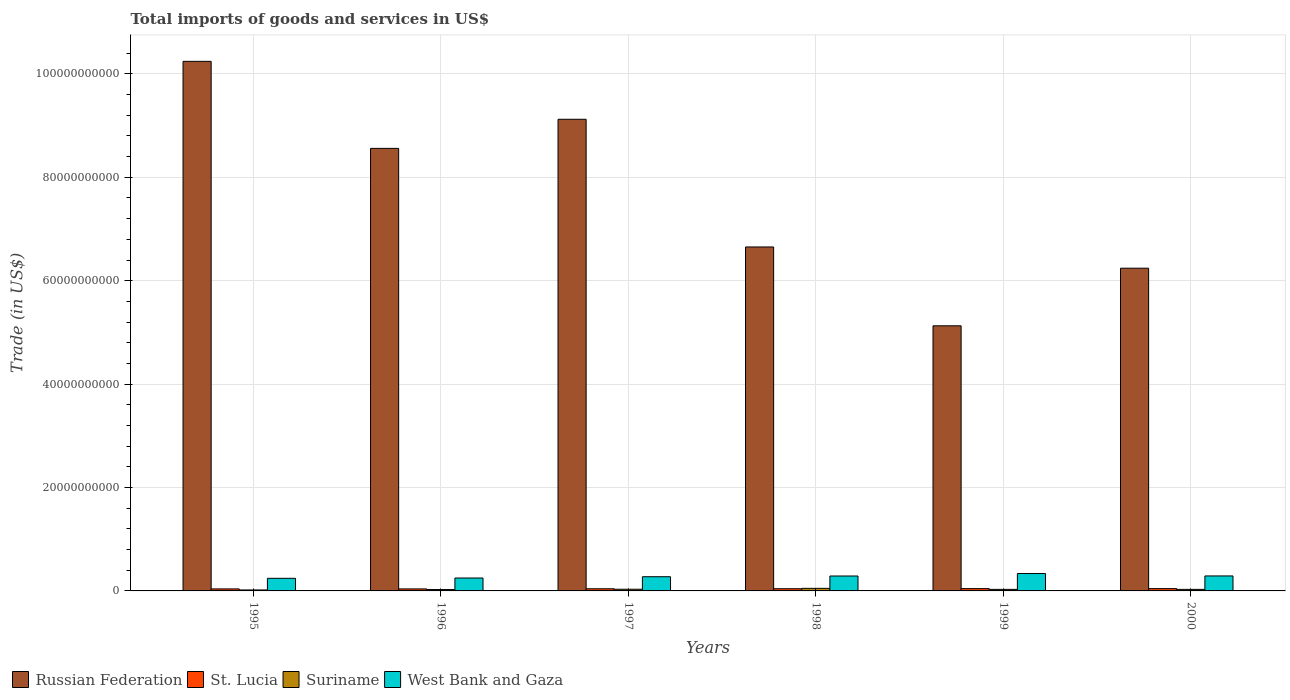How many groups of bars are there?
Offer a terse response. 6. Are the number of bars per tick equal to the number of legend labels?
Offer a very short reply. Yes. Are the number of bars on each tick of the X-axis equal?
Your answer should be compact. Yes. How many bars are there on the 3rd tick from the left?
Provide a short and direct response. 4. How many bars are there on the 2nd tick from the right?
Ensure brevity in your answer.  4. What is the total imports of goods and services in Suriname in 2000?
Provide a succinct answer. 2.96e+08. Across all years, what is the maximum total imports of goods and services in Suriname?
Provide a succinct answer. 4.96e+08. Across all years, what is the minimum total imports of goods and services in Suriname?
Make the answer very short. 1.89e+08. What is the total total imports of goods and services in Russian Federation in the graph?
Your answer should be compact. 4.59e+11. What is the difference between the total imports of goods and services in Suriname in 1997 and that in 2000?
Your answer should be compact. 2.73e+07. What is the difference between the total imports of goods and services in West Bank and Gaza in 1996 and the total imports of goods and services in Suriname in 1995?
Your response must be concise. 2.31e+09. What is the average total imports of goods and services in Suriname per year?
Offer a very short reply. 3.11e+08. In the year 2000, what is the difference between the total imports of goods and services in Suriname and total imports of goods and services in West Bank and Gaza?
Keep it short and to the point. -2.60e+09. What is the ratio of the total imports of goods and services in Suriname in 1997 to that in 1999?
Your response must be concise. 1.09. Is the total imports of goods and services in West Bank and Gaza in 1997 less than that in 2000?
Offer a very short reply. Yes. What is the difference between the highest and the second highest total imports of goods and services in West Bank and Gaza?
Make the answer very short. 4.66e+08. What is the difference between the highest and the lowest total imports of goods and services in Russian Federation?
Ensure brevity in your answer.  5.11e+1. Is the sum of the total imports of goods and services in West Bank and Gaza in 1996 and 1997 greater than the maximum total imports of goods and services in Russian Federation across all years?
Give a very brief answer. No. What does the 3rd bar from the left in 1995 represents?
Your answer should be compact. Suriname. What does the 3rd bar from the right in 1995 represents?
Your answer should be compact. St. Lucia. Is it the case that in every year, the sum of the total imports of goods and services in Suriname and total imports of goods and services in West Bank and Gaza is greater than the total imports of goods and services in Russian Federation?
Provide a short and direct response. No. Are all the bars in the graph horizontal?
Ensure brevity in your answer.  No. What is the difference between two consecutive major ticks on the Y-axis?
Keep it short and to the point. 2.00e+1. Are the values on the major ticks of Y-axis written in scientific E-notation?
Give a very brief answer. No. Does the graph contain grids?
Offer a very short reply. Yes. Where does the legend appear in the graph?
Offer a terse response. Bottom left. How are the legend labels stacked?
Your answer should be compact. Horizontal. What is the title of the graph?
Offer a terse response. Total imports of goods and services in US$. Does "Eritrea" appear as one of the legend labels in the graph?
Give a very brief answer. No. What is the label or title of the X-axis?
Make the answer very short. Years. What is the label or title of the Y-axis?
Provide a short and direct response. Trade (in US$). What is the Trade (in US$) of Russian Federation in 1995?
Keep it short and to the point. 1.02e+11. What is the Trade (in US$) of St. Lucia in 1995?
Make the answer very short. 3.89e+08. What is the Trade (in US$) in Suriname in 1995?
Keep it short and to the point. 1.89e+08. What is the Trade (in US$) in West Bank and Gaza in 1995?
Your answer should be very brief. 2.44e+09. What is the Trade (in US$) of Russian Federation in 1996?
Offer a terse response. 8.56e+1. What is the Trade (in US$) of St. Lucia in 1996?
Provide a succinct answer. 3.88e+08. What is the Trade (in US$) of Suriname in 1996?
Provide a succinct answer. 2.65e+08. What is the Trade (in US$) in West Bank and Gaza in 1996?
Make the answer very short. 2.50e+09. What is the Trade (in US$) in Russian Federation in 1997?
Provide a short and direct response. 9.12e+1. What is the Trade (in US$) in St. Lucia in 1997?
Offer a very short reply. 4.14e+08. What is the Trade (in US$) in Suriname in 1997?
Your answer should be compact. 3.23e+08. What is the Trade (in US$) in West Bank and Gaza in 1997?
Offer a very short reply. 2.75e+09. What is the Trade (in US$) of Russian Federation in 1998?
Provide a short and direct response. 6.65e+1. What is the Trade (in US$) of St. Lucia in 1998?
Provide a short and direct response. 4.24e+08. What is the Trade (in US$) in Suriname in 1998?
Offer a terse response. 4.96e+08. What is the Trade (in US$) in West Bank and Gaza in 1998?
Give a very brief answer. 2.89e+09. What is the Trade (in US$) in Russian Federation in 1999?
Provide a succinct answer. 5.13e+1. What is the Trade (in US$) of St. Lucia in 1999?
Offer a very short reply. 4.45e+08. What is the Trade (in US$) of Suriname in 1999?
Give a very brief answer. 2.98e+08. What is the Trade (in US$) of West Bank and Gaza in 1999?
Your answer should be very brief. 3.36e+09. What is the Trade (in US$) in Russian Federation in 2000?
Keep it short and to the point. 6.24e+1. What is the Trade (in US$) in St. Lucia in 2000?
Your answer should be very brief. 4.46e+08. What is the Trade (in US$) of Suriname in 2000?
Provide a short and direct response. 2.96e+08. What is the Trade (in US$) in West Bank and Gaza in 2000?
Provide a succinct answer. 2.90e+09. Across all years, what is the maximum Trade (in US$) in Russian Federation?
Offer a terse response. 1.02e+11. Across all years, what is the maximum Trade (in US$) in St. Lucia?
Provide a short and direct response. 4.46e+08. Across all years, what is the maximum Trade (in US$) of Suriname?
Your response must be concise. 4.96e+08. Across all years, what is the maximum Trade (in US$) in West Bank and Gaza?
Offer a very short reply. 3.36e+09. Across all years, what is the minimum Trade (in US$) in Russian Federation?
Keep it short and to the point. 5.13e+1. Across all years, what is the minimum Trade (in US$) in St. Lucia?
Offer a terse response. 3.88e+08. Across all years, what is the minimum Trade (in US$) in Suriname?
Provide a short and direct response. 1.89e+08. Across all years, what is the minimum Trade (in US$) in West Bank and Gaza?
Offer a very short reply. 2.44e+09. What is the total Trade (in US$) of Russian Federation in the graph?
Offer a very short reply. 4.59e+11. What is the total Trade (in US$) of St. Lucia in the graph?
Offer a terse response. 2.51e+09. What is the total Trade (in US$) of Suriname in the graph?
Give a very brief answer. 1.87e+09. What is the total Trade (in US$) in West Bank and Gaza in the graph?
Your answer should be compact. 1.68e+1. What is the difference between the Trade (in US$) in Russian Federation in 1995 and that in 1996?
Ensure brevity in your answer.  1.68e+1. What is the difference between the Trade (in US$) in St. Lucia in 1995 and that in 1996?
Offer a terse response. 7.00e+05. What is the difference between the Trade (in US$) of Suriname in 1995 and that in 1996?
Give a very brief answer. -7.59e+07. What is the difference between the Trade (in US$) in West Bank and Gaza in 1995 and that in 1996?
Your response must be concise. -5.62e+07. What is the difference between the Trade (in US$) in Russian Federation in 1995 and that in 1997?
Your response must be concise. 1.12e+1. What is the difference between the Trade (in US$) in St. Lucia in 1995 and that in 1997?
Make the answer very short. -2.56e+07. What is the difference between the Trade (in US$) in Suriname in 1995 and that in 1997?
Make the answer very short. -1.35e+08. What is the difference between the Trade (in US$) of West Bank and Gaza in 1995 and that in 1997?
Provide a short and direct response. -3.06e+08. What is the difference between the Trade (in US$) of Russian Federation in 1995 and that in 1998?
Make the answer very short. 3.59e+1. What is the difference between the Trade (in US$) in St. Lucia in 1995 and that in 1998?
Offer a very short reply. -3.56e+07. What is the difference between the Trade (in US$) of Suriname in 1995 and that in 1998?
Your response must be concise. -3.07e+08. What is the difference between the Trade (in US$) of West Bank and Gaza in 1995 and that in 1998?
Your answer should be very brief. -4.45e+08. What is the difference between the Trade (in US$) in Russian Federation in 1995 and that in 1999?
Offer a very short reply. 5.11e+1. What is the difference between the Trade (in US$) of St. Lucia in 1995 and that in 1999?
Make the answer very short. -5.65e+07. What is the difference between the Trade (in US$) in Suriname in 1995 and that in 1999?
Make the answer very short. -1.09e+08. What is the difference between the Trade (in US$) of West Bank and Gaza in 1995 and that in 1999?
Provide a short and direct response. -9.24e+08. What is the difference between the Trade (in US$) in Russian Federation in 1995 and that in 2000?
Provide a short and direct response. 4.00e+1. What is the difference between the Trade (in US$) of St. Lucia in 1995 and that in 2000?
Ensure brevity in your answer.  -5.72e+07. What is the difference between the Trade (in US$) of Suriname in 1995 and that in 2000?
Keep it short and to the point. -1.07e+08. What is the difference between the Trade (in US$) in West Bank and Gaza in 1995 and that in 2000?
Ensure brevity in your answer.  -4.57e+08. What is the difference between the Trade (in US$) of Russian Federation in 1996 and that in 1997?
Your answer should be compact. -5.63e+09. What is the difference between the Trade (in US$) of St. Lucia in 1996 and that in 1997?
Provide a succinct answer. -2.63e+07. What is the difference between the Trade (in US$) in Suriname in 1996 and that in 1997?
Offer a terse response. -5.87e+07. What is the difference between the Trade (in US$) in West Bank and Gaza in 1996 and that in 1997?
Give a very brief answer. -2.50e+08. What is the difference between the Trade (in US$) of Russian Federation in 1996 and that in 1998?
Provide a succinct answer. 1.91e+1. What is the difference between the Trade (in US$) of St. Lucia in 1996 and that in 1998?
Give a very brief answer. -3.63e+07. What is the difference between the Trade (in US$) in Suriname in 1996 and that in 1998?
Keep it short and to the point. -2.31e+08. What is the difference between the Trade (in US$) of West Bank and Gaza in 1996 and that in 1998?
Your answer should be compact. -3.89e+08. What is the difference between the Trade (in US$) of Russian Federation in 1996 and that in 1999?
Offer a very short reply. 3.43e+1. What is the difference between the Trade (in US$) in St. Lucia in 1996 and that in 1999?
Make the answer very short. -5.72e+07. What is the difference between the Trade (in US$) of Suriname in 1996 and that in 1999?
Offer a terse response. -3.31e+07. What is the difference between the Trade (in US$) in West Bank and Gaza in 1996 and that in 1999?
Your answer should be very brief. -8.67e+08. What is the difference between the Trade (in US$) in Russian Federation in 1996 and that in 2000?
Offer a terse response. 2.32e+1. What is the difference between the Trade (in US$) of St. Lucia in 1996 and that in 2000?
Keep it short and to the point. -5.79e+07. What is the difference between the Trade (in US$) in Suriname in 1996 and that in 2000?
Provide a short and direct response. -3.15e+07. What is the difference between the Trade (in US$) in West Bank and Gaza in 1996 and that in 2000?
Provide a short and direct response. -4.01e+08. What is the difference between the Trade (in US$) of Russian Federation in 1997 and that in 1998?
Offer a terse response. 2.47e+1. What is the difference between the Trade (in US$) in St. Lucia in 1997 and that in 1998?
Your answer should be compact. -1.00e+07. What is the difference between the Trade (in US$) in Suriname in 1997 and that in 1998?
Your answer should be very brief. -1.73e+08. What is the difference between the Trade (in US$) of West Bank and Gaza in 1997 and that in 1998?
Your answer should be very brief. -1.39e+08. What is the difference between the Trade (in US$) in Russian Federation in 1997 and that in 1999?
Keep it short and to the point. 3.99e+1. What is the difference between the Trade (in US$) of St. Lucia in 1997 and that in 1999?
Provide a short and direct response. -3.09e+07. What is the difference between the Trade (in US$) of Suriname in 1997 and that in 1999?
Provide a succinct answer. 2.56e+07. What is the difference between the Trade (in US$) of West Bank and Gaza in 1997 and that in 1999?
Keep it short and to the point. -6.17e+08. What is the difference between the Trade (in US$) of Russian Federation in 1997 and that in 2000?
Your response must be concise. 2.88e+1. What is the difference between the Trade (in US$) in St. Lucia in 1997 and that in 2000?
Give a very brief answer. -3.17e+07. What is the difference between the Trade (in US$) of Suriname in 1997 and that in 2000?
Offer a very short reply. 2.73e+07. What is the difference between the Trade (in US$) in West Bank and Gaza in 1997 and that in 2000?
Give a very brief answer. -1.51e+08. What is the difference between the Trade (in US$) of Russian Federation in 1998 and that in 1999?
Provide a short and direct response. 1.52e+1. What is the difference between the Trade (in US$) of St. Lucia in 1998 and that in 1999?
Your response must be concise. -2.08e+07. What is the difference between the Trade (in US$) in Suriname in 1998 and that in 1999?
Your answer should be compact. 1.98e+08. What is the difference between the Trade (in US$) of West Bank and Gaza in 1998 and that in 1999?
Ensure brevity in your answer.  -4.78e+08. What is the difference between the Trade (in US$) in Russian Federation in 1998 and that in 2000?
Give a very brief answer. 4.11e+09. What is the difference between the Trade (in US$) of St. Lucia in 1998 and that in 2000?
Your response must be concise. -2.16e+07. What is the difference between the Trade (in US$) of Suriname in 1998 and that in 2000?
Ensure brevity in your answer.  2.00e+08. What is the difference between the Trade (in US$) of West Bank and Gaza in 1998 and that in 2000?
Ensure brevity in your answer.  -1.18e+07. What is the difference between the Trade (in US$) of Russian Federation in 1999 and that in 2000?
Offer a terse response. -1.11e+1. What is the difference between the Trade (in US$) of St. Lucia in 1999 and that in 2000?
Give a very brief answer. -7.96e+05. What is the difference between the Trade (in US$) of Suriname in 1999 and that in 2000?
Provide a succinct answer. 1.62e+06. What is the difference between the Trade (in US$) of West Bank and Gaza in 1999 and that in 2000?
Ensure brevity in your answer.  4.66e+08. What is the difference between the Trade (in US$) in Russian Federation in 1995 and the Trade (in US$) in St. Lucia in 1996?
Your answer should be very brief. 1.02e+11. What is the difference between the Trade (in US$) in Russian Federation in 1995 and the Trade (in US$) in Suriname in 1996?
Make the answer very short. 1.02e+11. What is the difference between the Trade (in US$) of Russian Federation in 1995 and the Trade (in US$) of West Bank and Gaza in 1996?
Ensure brevity in your answer.  9.99e+1. What is the difference between the Trade (in US$) of St. Lucia in 1995 and the Trade (in US$) of Suriname in 1996?
Provide a short and direct response. 1.24e+08. What is the difference between the Trade (in US$) in St. Lucia in 1995 and the Trade (in US$) in West Bank and Gaza in 1996?
Ensure brevity in your answer.  -2.11e+09. What is the difference between the Trade (in US$) of Suriname in 1995 and the Trade (in US$) of West Bank and Gaza in 1996?
Your response must be concise. -2.31e+09. What is the difference between the Trade (in US$) in Russian Federation in 1995 and the Trade (in US$) in St. Lucia in 1997?
Provide a short and direct response. 1.02e+11. What is the difference between the Trade (in US$) of Russian Federation in 1995 and the Trade (in US$) of Suriname in 1997?
Keep it short and to the point. 1.02e+11. What is the difference between the Trade (in US$) of Russian Federation in 1995 and the Trade (in US$) of West Bank and Gaza in 1997?
Offer a very short reply. 9.97e+1. What is the difference between the Trade (in US$) of St. Lucia in 1995 and the Trade (in US$) of Suriname in 1997?
Your answer should be compact. 6.53e+07. What is the difference between the Trade (in US$) in St. Lucia in 1995 and the Trade (in US$) in West Bank and Gaza in 1997?
Ensure brevity in your answer.  -2.36e+09. What is the difference between the Trade (in US$) in Suriname in 1995 and the Trade (in US$) in West Bank and Gaza in 1997?
Your answer should be very brief. -2.56e+09. What is the difference between the Trade (in US$) in Russian Federation in 1995 and the Trade (in US$) in St. Lucia in 1998?
Your answer should be very brief. 1.02e+11. What is the difference between the Trade (in US$) in Russian Federation in 1995 and the Trade (in US$) in Suriname in 1998?
Your answer should be very brief. 1.02e+11. What is the difference between the Trade (in US$) of Russian Federation in 1995 and the Trade (in US$) of West Bank and Gaza in 1998?
Your answer should be compact. 9.95e+1. What is the difference between the Trade (in US$) of St. Lucia in 1995 and the Trade (in US$) of Suriname in 1998?
Ensure brevity in your answer.  -1.07e+08. What is the difference between the Trade (in US$) in St. Lucia in 1995 and the Trade (in US$) in West Bank and Gaza in 1998?
Offer a terse response. -2.50e+09. What is the difference between the Trade (in US$) of Suriname in 1995 and the Trade (in US$) of West Bank and Gaza in 1998?
Offer a very short reply. -2.70e+09. What is the difference between the Trade (in US$) of Russian Federation in 1995 and the Trade (in US$) of St. Lucia in 1999?
Make the answer very short. 1.02e+11. What is the difference between the Trade (in US$) in Russian Federation in 1995 and the Trade (in US$) in Suriname in 1999?
Offer a terse response. 1.02e+11. What is the difference between the Trade (in US$) in Russian Federation in 1995 and the Trade (in US$) in West Bank and Gaza in 1999?
Provide a short and direct response. 9.91e+1. What is the difference between the Trade (in US$) of St. Lucia in 1995 and the Trade (in US$) of Suriname in 1999?
Your answer should be very brief. 9.09e+07. What is the difference between the Trade (in US$) in St. Lucia in 1995 and the Trade (in US$) in West Bank and Gaza in 1999?
Your response must be concise. -2.98e+09. What is the difference between the Trade (in US$) of Suriname in 1995 and the Trade (in US$) of West Bank and Gaza in 1999?
Ensure brevity in your answer.  -3.17e+09. What is the difference between the Trade (in US$) in Russian Federation in 1995 and the Trade (in US$) in St. Lucia in 2000?
Your answer should be very brief. 1.02e+11. What is the difference between the Trade (in US$) in Russian Federation in 1995 and the Trade (in US$) in Suriname in 2000?
Keep it short and to the point. 1.02e+11. What is the difference between the Trade (in US$) of Russian Federation in 1995 and the Trade (in US$) of West Bank and Gaza in 2000?
Your response must be concise. 9.95e+1. What is the difference between the Trade (in US$) in St. Lucia in 1995 and the Trade (in US$) in Suriname in 2000?
Offer a terse response. 9.25e+07. What is the difference between the Trade (in US$) in St. Lucia in 1995 and the Trade (in US$) in West Bank and Gaza in 2000?
Give a very brief answer. -2.51e+09. What is the difference between the Trade (in US$) of Suriname in 1995 and the Trade (in US$) of West Bank and Gaza in 2000?
Offer a terse response. -2.71e+09. What is the difference between the Trade (in US$) of Russian Federation in 1996 and the Trade (in US$) of St. Lucia in 1997?
Your response must be concise. 8.52e+1. What is the difference between the Trade (in US$) of Russian Federation in 1996 and the Trade (in US$) of Suriname in 1997?
Ensure brevity in your answer.  8.53e+1. What is the difference between the Trade (in US$) in Russian Federation in 1996 and the Trade (in US$) in West Bank and Gaza in 1997?
Offer a terse response. 8.28e+1. What is the difference between the Trade (in US$) in St. Lucia in 1996 and the Trade (in US$) in Suriname in 1997?
Keep it short and to the point. 6.46e+07. What is the difference between the Trade (in US$) in St. Lucia in 1996 and the Trade (in US$) in West Bank and Gaza in 1997?
Give a very brief answer. -2.36e+09. What is the difference between the Trade (in US$) in Suriname in 1996 and the Trade (in US$) in West Bank and Gaza in 1997?
Make the answer very short. -2.48e+09. What is the difference between the Trade (in US$) of Russian Federation in 1996 and the Trade (in US$) of St. Lucia in 1998?
Provide a succinct answer. 8.52e+1. What is the difference between the Trade (in US$) in Russian Federation in 1996 and the Trade (in US$) in Suriname in 1998?
Your answer should be compact. 8.51e+1. What is the difference between the Trade (in US$) of Russian Federation in 1996 and the Trade (in US$) of West Bank and Gaza in 1998?
Offer a very short reply. 8.27e+1. What is the difference between the Trade (in US$) in St. Lucia in 1996 and the Trade (in US$) in Suriname in 1998?
Offer a terse response. -1.08e+08. What is the difference between the Trade (in US$) in St. Lucia in 1996 and the Trade (in US$) in West Bank and Gaza in 1998?
Make the answer very short. -2.50e+09. What is the difference between the Trade (in US$) in Suriname in 1996 and the Trade (in US$) in West Bank and Gaza in 1998?
Your answer should be compact. -2.62e+09. What is the difference between the Trade (in US$) in Russian Federation in 1996 and the Trade (in US$) in St. Lucia in 1999?
Keep it short and to the point. 8.51e+1. What is the difference between the Trade (in US$) in Russian Federation in 1996 and the Trade (in US$) in Suriname in 1999?
Give a very brief answer. 8.53e+1. What is the difference between the Trade (in US$) of Russian Federation in 1996 and the Trade (in US$) of West Bank and Gaza in 1999?
Provide a short and direct response. 8.22e+1. What is the difference between the Trade (in US$) of St. Lucia in 1996 and the Trade (in US$) of Suriname in 1999?
Offer a very short reply. 9.02e+07. What is the difference between the Trade (in US$) of St. Lucia in 1996 and the Trade (in US$) of West Bank and Gaza in 1999?
Ensure brevity in your answer.  -2.98e+09. What is the difference between the Trade (in US$) of Suriname in 1996 and the Trade (in US$) of West Bank and Gaza in 1999?
Offer a very short reply. -3.10e+09. What is the difference between the Trade (in US$) of Russian Federation in 1996 and the Trade (in US$) of St. Lucia in 2000?
Offer a very short reply. 8.51e+1. What is the difference between the Trade (in US$) in Russian Federation in 1996 and the Trade (in US$) in Suriname in 2000?
Ensure brevity in your answer.  8.53e+1. What is the difference between the Trade (in US$) in Russian Federation in 1996 and the Trade (in US$) in West Bank and Gaza in 2000?
Provide a succinct answer. 8.27e+1. What is the difference between the Trade (in US$) of St. Lucia in 1996 and the Trade (in US$) of Suriname in 2000?
Give a very brief answer. 9.18e+07. What is the difference between the Trade (in US$) of St. Lucia in 1996 and the Trade (in US$) of West Bank and Gaza in 2000?
Give a very brief answer. -2.51e+09. What is the difference between the Trade (in US$) of Suriname in 1996 and the Trade (in US$) of West Bank and Gaza in 2000?
Provide a short and direct response. -2.63e+09. What is the difference between the Trade (in US$) of Russian Federation in 1997 and the Trade (in US$) of St. Lucia in 1998?
Provide a short and direct response. 9.08e+1. What is the difference between the Trade (in US$) in Russian Federation in 1997 and the Trade (in US$) in Suriname in 1998?
Keep it short and to the point. 9.07e+1. What is the difference between the Trade (in US$) of Russian Federation in 1997 and the Trade (in US$) of West Bank and Gaza in 1998?
Your response must be concise. 8.83e+1. What is the difference between the Trade (in US$) of St. Lucia in 1997 and the Trade (in US$) of Suriname in 1998?
Offer a terse response. -8.17e+07. What is the difference between the Trade (in US$) of St. Lucia in 1997 and the Trade (in US$) of West Bank and Gaza in 1998?
Give a very brief answer. -2.47e+09. What is the difference between the Trade (in US$) of Suriname in 1997 and the Trade (in US$) of West Bank and Gaza in 1998?
Your answer should be compact. -2.56e+09. What is the difference between the Trade (in US$) in Russian Federation in 1997 and the Trade (in US$) in St. Lucia in 1999?
Give a very brief answer. 9.08e+1. What is the difference between the Trade (in US$) of Russian Federation in 1997 and the Trade (in US$) of Suriname in 1999?
Your answer should be compact. 9.09e+1. What is the difference between the Trade (in US$) in Russian Federation in 1997 and the Trade (in US$) in West Bank and Gaza in 1999?
Offer a terse response. 8.79e+1. What is the difference between the Trade (in US$) of St. Lucia in 1997 and the Trade (in US$) of Suriname in 1999?
Your answer should be very brief. 1.16e+08. What is the difference between the Trade (in US$) in St. Lucia in 1997 and the Trade (in US$) in West Bank and Gaza in 1999?
Your response must be concise. -2.95e+09. What is the difference between the Trade (in US$) of Suriname in 1997 and the Trade (in US$) of West Bank and Gaza in 1999?
Offer a terse response. -3.04e+09. What is the difference between the Trade (in US$) of Russian Federation in 1997 and the Trade (in US$) of St. Lucia in 2000?
Offer a very short reply. 9.08e+1. What is the difference between the Trade (in US$) in Russian Federation in 1997 and the Trade (in US$) in Suriname in 2000?
Keep it short and to the point. 9.09e+1. What is the difference between the Trade (in US$) in Russian Federation in 1997 and the Trade (in US$) in West Bank and Gaza in 2000?
Your answer should be very brief. 8.83e+1. What is the difference between the Trade (in US$) of St. Lucia in 1997 and the Trade (in US$) of Suriname in 2000?
Offer a terse response. 1.18e+08. What is the difference between the Trade (in US$) in St. Lucia in 1997 and the Trade (in US$) in West Bank and Gaza in 2000?
Ensure brevity in your answer.  -2.48e+09. What is the difference between the Trade (in US$) in Suriname in 1997 and the Trade (in US$) in West Bank and Gaza in 2000?
Ensure brevity in your answer.  -2.57e+09. What is the difference between the Trade (in US$) in Russian Federation in 1998 and the Trade (in US$) in St. Lucia in 1999?
Ensure brevity in your answer.  6.61e+1. What is the difference between the Trade (in US$) in Russian Federation in 1998 and the Trade (in US$) in Suriname in 1999?
Your answer should be compact. 6.62e+1. What is the difference between the Trade (in US$) in Russian Federation in 1998 and the Trade (in US$) in West Bank and Gaza in 1999?
Provide a short and direct response. 6.32e+1. What is the difference between the Trade (in US$) in St. Lucia in 1998 and the Trade (in US$) in Suriname in 1999?
Provide a short and direct response. 1.27e+08. What is the difference between the Trade (in US$) of St. Lucia in 1998 and the Trade (in US$) of West Bank and Gaza in 1999?
Your answer should be very brief. -2.94e+09. What is the difference between the Trade (in US$) of Suriname in 1998 and the Trade (in US$) of West Bank and Gaza in 1999?
Offer a terse response. -2.87e+09. What is the difference between the Trade (in US$) in Russian Federation in 1998 and the Trade (in US$) in St. Lucia in 2000?
Your answer should be very brief. 6.61e+1. What is the difference between the Trade (in US$) of Russian Federation in 1998 and the Trade (in US$) of Suriname in 2000?
Your answer should be compact. 6.62e+1. What is the difference between the Trade (in US$) in Russian Federation in 1998 and the Trade (in US$) in West Bank and Gaza in 2000?
Provide a succinct answer. 6.36e+1. What is the difference between the Trade (in US$) in St. Lucia in 1998 and the Trade (in US$) in Suriname in 2000?
Your answer should be very brief. 1.28e+08. What is the difference between the Trade (in US$) of St. Lucia in 1998 and the Trade (in US$) of West Bank and Gaza in 2000?
Your response must be concise. -2.47e+09. What is the difference between the Trade (in US$) in Suriname in 1998 and the Trade (in US$) in West Bank and Gaza in 2000?
Offer a very short reply. -2.40e+09. What is the difference between the Trade (in US$) in Russian Federation in 1999 and the Trade (in US$) in St. Lucia in 2000?
Provide a short and direct response. 5.08e+1. What is the difference between the Trade (in US$) in Russian Federation in 1999 and the Trade (in US$) in Suriname in 2000?
Ensure brevity in your answer.  5.10e+1. What is the difference between the Trade (in US$) of Russian Federation in 1999 and the Trade (in US$) of West Bank and Gaza in 2000?
Your answer should be compact. 4.84e+1. What is the difference between the Trade (in US$) in St. Lucia in 1999 and the Trade (in US$) in Suriname in 2000?
Keep it short and to the point. 1.49e+08. What is the difference between the Trade (in US$) of St. Lucia in 1999 and the Trade (in US$) of West Bank and Gaza in 2000?
Provide a short and direct response. -2.45e+09. What is the difference between the Trade (in US$) in Suriname in 1999 and the Trade (in US$) in West Bank and Gaza in 2000?
Provide a short and direct response. -2.60e+09. What is the average Trade (in US$) in Russian Federation per year?
Make the answer very short. 7.66e+1. What is the average Trade (in US$) of St. Lucia per year?
Make the answer very short. 4.18e+08. What is the average Trade (in US$) in Suriname per year?
Make the answer very short. 3.11e+08. What is the average Trade (in US$) of West Bank and Gaza per year?
Provide a succinct answer. 2.80e+09. In the year 1995, what is the difference between the Trade (in US$) in Russian Federation and Trade (in US$) in St. Lucia?
Keep it short and to the point. 1.02e+11. In the year 1995, what is the difference between the Trade (in US$) of Russian Federation and Trade (in US$) of Suriname?
Provide a short and direct response. 1.02e+11. In the year 1995, what is the difference between the Trade (in US$) in Russian Federation and Trade (in US$) in West Bank and Gaza?
Make the answer very short. 1.00e+11. In the year 1995, what is the difference between the Trade (in US$) of St. Lucia and Trade (in US$) of Suriname?
Your response must be concise. 2.00e+08. In the year 1995, what is the difference between the Trade (in US$) in St. Lucia and Trade (in US$) in West Bank and Gaza?
Offer a very short reply. -2.05e+09. In the year 1995, what is the difference between the Trade (in US$) of Suriname and Trade (in US$) of West Bank and Gaza?
Provide a short and direct response. -2.25e+09. In the year 1996, what is the difference between the Trade (in US$) of Russian Federation and Trade (in US$) of St. Lucia?
Offer a very short reply. 8.52e+1. In the year 1996, what is the difference between the Trade (in US$) in Russian Federation and Trade (in US$) in Suriname?
Give a very brief answer. 8.53e+1. In the year 1996, what is the difference between the Trade (in US$) of Russian Federation and Trade (in US$) of West Bank and Gaza?
Make the answer very short. 8.31e+1. In the year 1996, what is the difference between the Trade (in US$) of St. Lucia and Trade (in US$) of Suriname?
Ensure brevity in your answer.  1.23e+08. In the year 1996, what is the difference between the Trade (in US$) of St. Lucia and Trade (in US$) of West Bank and Gaza?
Offer a very short reply. -2.11e+09. In the year 1996, what is the difference between the Trade (in US$) of Suriname and Trade (in US$) of West Bank and Gaza?
Make the answer very short. -2.23e+09. In the year 1997, what is the difference between the Trade (in US$) of Russian Federation and Trade (in US$) of St. Lucia?
Offer a terse response. 9.08e+1. In the year 1997, what is the difference between the Trade (in US$) in Russian Federation and Trade (in US$) in Suriname?
Ensure brevity in your answer.  9.09e+1. In the year 1997, what is the difference between the Trade (in US$) of Russian Federation and Trade (in US$) of West Bank and Gaza?
Provide a succinct answer. 8.85e+1. In the year 1997, what is the difference between the Trade (in US$) in St. Lucia and Trade (in US$) in Suriname?
Give a very brief answer. 9.08e+07. In the year 1997, what is the difference between the Trade (in US$) in St. Lucia and Trade (in US$) in West Bank and Gaza?
Offer a very short reply. -2.33e+09. In the year 1997, what is the difference between the Trade (in US$) in Suriname and Trade (in US$) in West Bank and Gaza?
Keep it short and to the point. -2.42e+09. In the year 1998, what is the difference between the Trade (in US$) in Russian Federation and Trade (in US$) in St. Lucia?
Offer a very short reply. 6.61e+1. In the year 1998, what is the difference between the Trade (in US$) in Russian Federation and Trade (in US$) in Suriname?
Give a very brief answer. 6.60e+1. In the year 1998, what is the difference between the Trade (in US$) of Russian Federation and Trade (in US$) of West Bank and Gaza?
Ensure brevity in your answer.  6.36e+1. In the year 1998, what is the difference between the Trade (in US$) of St. Lucia and Trade (in US$) of Suriname?
Ensure brevity in your answer.  -7.17e+07. In the year 1998, what is the difference between the Trade (in US$) in St. Lucia and Trade (in US$) in West Bank and Gaza?
Your answer should be compact. -2.46e+09. In the year 1998, what is the difference between the Trade (in US$) of Suriname and Trade (in US$) of West Bank and Gaza?
Provide a short and direct response. -2.39e+09. In the year 1999, what is the difference between the Trade (in US$) of Russian Federation and Trade (in US$) of St. Lucia?
Provide a succinct answer. 5.08e+1. In the year 1999, what is the difference between the Trade (in US$) in Russian Federation and Trade (in US$) in Suriname?
Keep it short and to the point. 5.10e+1. In the year 1999, what is the difference between the Trade (in US$) in Russian Federation and Trade (in US$) in West Bank and Gaza?
Your response must be concise. 4.79e+1. In the year 1999, what is the difference between the Trade (in US$) in St. Lucia and Trade (in US$) in Suriname?
Your answer should be compact. 1.47e+08. In the year 1999, what is the difference between the Trade (in US$) in St. Lucia and Trade (in US$) in West Bank and Gaza?
Ensure brevity in your answer.  -2.92e+09. In the year 1999, what is the difference between the Trade (in US$) in Suriname and Trade (in US$) in West Bank and Gaza?
Keep it short and to the point. -3.07e+09. In the year 2000, what is the difference between the Trade (in US$) in Russian Federation and Trade (in US$) in St. Lucia?
Provide a short and direct response. 6.20e+1. In the year 2000, what is the difference between the Trade (in US$) of Russian Federation and Trade (in US$) of Suriname?
Give a very brief answer. 6.21e+1. In the year 2000, what is the difference between the Trade (in US$) in Russian Federation and Trade (in US$) in West Bank and Gaza?
Make the answer very short. 5.95e+1. In the year 2000, what is the difference between the Trade (in US$) of St. Lucia and Trade (in US$) of Suriname?
Your response must be concise. 1.50e+08. In the year 2000, what is the difference between the Trade (in US$) in St. Lucia and Trade (in US$) in West Bank and Gaza?
Your answer should be compact. -2.45e+09. In the year 2000, what is the difference between the Trade (in US$) of Suriname and Trade (in US$) of West Bank and Gaza?
Your response must be concise. -2.60e+09. What is the ratio of the Trade (in US$) of Russian Federation in 1995 to that in 1996?
Make the answer very short. 1.2. What is the ratio of the Trade (in US$) of Suriname in 1995 to that in 1996?
Provide a succinct answer. 0.71. What is the ratio of the Trade (in US$) of West Bank and Gaza in 1995 to that in 1996?
Provide a short and direct response. 0.98. What is the ratio of the Trade (in US$) in Russian Federation in 1995 to that in 1997?
Provide a short and direct response. 1.12. What is the ratio of the Trade (in US$) in St. Lucia in 1995 to that in 1997?
Provide a succinct answer. 0.94. What is the ratio of the Trade (in US$) in Suriname in 1995 to that in 1997?
Make the answer very short. 0.58. What is the ratio of the Trade (in US$) of West Bank and Gaza in 1995 to that in 1997?
Make the answer very short. 0.89. What is the ratio of the Trade (in US$) in Russian Federation in 1995 to that in 1998?
Provide a succinct answer. 1.54. What is the ratio of the Trade (in US$) in St. Lucia in 1995 to that in 1998?
Offer a terse response. 0.92. What is the ratio of the Trade (in US$) in Suriname in 1995 to that in 1998?
Offer a terse response. 0.38. What is the ratio of the Trade (in US$) in West Bank and Gaza in 1995 to that in 1998?
Your response must be concise. 0.85. What is the ratio of the Trade (in US$) of Russian Federation in 1995 to that in 1999?
Offer a terse response. 2. What is the ratio of the Trade (in US$) in St. Lucia in 1995 to that in 1999?
Provide a short and direct response. 0.87. What is the ratio of the Trade (in US$) in Suriname in 1995 to that in 1999?
Make the answer very short. 0.63. What is the ratio of the Trade (in US$) in West Bank and Gaza in 1995 to that in 1999?
Ensure brevity in your answer.  0.73. What is the ratio of the Trade (in US$) of Russian Federation in 1995 to that in 2000?
Your answer should be very brief. 1.64. What is the ratio of the Trade (in US$) in St. Lucia in 1995 to that in 2000?
Offer a terse response. 0.87. What is the ratio of the Trade (in US$) in Suriname in 1995 to that in 2000?
Provide a short and direct response. 0.64. What is the ratio of the Trade (in US$) of West Bank and Gaza in 1995 to that in 2000?
Your response must be concise. 0.84. What is the ratio of the Trade (in US$) in Russian Federation in 1996 to that in 1997?
Your response must be concise. 0.94. What is the ratio of the Trade (in US$) of St. Lucia in 1996 to that in 1997?
Provide a short and direct response. 0.94. What is the ratio of the Trade (in US$) of Suriname in 1996 to that in 1997?
Give a very brief answer. 0.82. What is the ratio of the Trade (in US$) of West Bank and Gaza in 1996 to that in 1997?
Your answer should be very brief. 0.91. What is the ratio of the Trade (in US$) in Russian Federation in 1996 to that in 1998?
Provide a succinct answer. 1.29. What is the ratio of the Trade (in US$) of St. Lucia in 1996 to that in 1998?
Your answer should be very brief. 0.91. What is the ratio of the Trade (in US$) in Suriname in 1996 to that in 1998?
Offer a very short reply. 0.53. What is the ratio of the Trade (in US$) of West Bank and Gaza in 1996 to that in 1998?
Make the answer very short. 0.87. What is the ratio of the Trade (in US$) in Russian Federation in 1996 to that in 1999?
Provide a short and direct response. 1.67. What is the ratio of the Trade (in US$) in St. Lucia in 1996 to that in 1999?
Ensure brevity in your answer.  0.87. What is the ratio of the Trade (in US$) in West Bank and Gaza in 1996 to that in 1999?
Offer a very short reply. 0.74. What is the ratio of the Trade (in US$) of Russian Federation in 1996 to that in 2000?
Make the answer very short. 1.37. What is the ratio of the Trade (in US$) of St. Lucia in 1996 to that in 2000?
Give a very brief answer. 0.87. What is the ratio of the Trade (in US$) of Suriname in 1996 to that in 2000?
Keep it short and to the point. 0.89. What is the ratio of the Trade (in US$) in West Bank and Gaza in 1996 to that in 2000?
Ensure brevity in your answer.  0.86. What is the ratio of the Trade (in US$) in Russian Federation in 1997 to that in 1998?
Provide a succinct answer. 1.37. What is the ratio of the Trade (in US$) of St. Lucia in 1997 to that in 1998?
Keep it short and to the point. 0.98. What is the ratio of the Trade (in US$) in Suriname in 1997 to that in 1998?
Your response must be concise. 0.65. What is the ratio of the Trade (in US$) of West Bank and Gaza in 1997 to that in 1998?
Offer a very short reply. 0.95. What is the ratio of the Trade (in US$) in Russian Federation in 1997 to that in 1999?
Provide a short and direct response. 1.78. What is the ratio of the Trade (in US$) in St. Lucia in 1997 to that in 1999?
Your answer should be very brief. 0.93. What is the ratio of the Trade (in US$) of Suriname in 1997 to that in 1999?
Keep it short and to the point. 1.09. What is the ratio of the Trade (in US$) of West Bank and Gaza in 1997 to that in 1999?
Make the answer very short. 0.82. What is the ratio of the Trade (in US$) in Russian Federation in 1997 to that in 2000?
Your response must be concise. 1.46. What is the ratio of the Trade (in US$) of St. Lucia in 1997 to that in 2000?
Provide a short and direct response. 0.93. What is the ratio of the Trade (in US$) of Suriname in 1997 to that in 2000?
Your answer should be compact. 1.09. What is the ratio of the Trade (in US$) of West Bank and Gaza in 1997 to that in 2000?
Your answer should be compact. 0.95. What is the ratio of the Trade (in US$) of Russian Federation in 1998 to that in 1999?
Offer a terse response. 1.3. What is the ratio of the Trade (in US$) of St. Lucia in 1998 to that in 1999?
Your response must be concise. 0.95. What is the ratio of the Trade (in US$) in Suriname in 1998 to that in 1999?
Provide a succinct answer. 1.67. What is the ratio of the Trade (in US$) of West Bank and Gaza in 1998 to that in 1999?
Ensure brevity in your answer.  0.86. What is the ratio of the Trade (in US$) of Russian Federation in 1998 to that in 2000?
Ensure brevity in your answer.  1.07. What is the ratio of the Trade (in US$) of St. Lucia in 1998 to that in 2000?
Offer a very short reply. 0.95. What is the ratio of the Trade (in US$) of Suriname in 1998 to that in 2000?
Give a very brief answer. 1.67. What is the ratio of the Trade (in US$) in Russian Federation in 1999 to that in 2000?
Offer a very short reply. 0.82. What is the ratio of the Trade (in US$) of Suriname in 1999 to that in 2000?
Your response must be concise. 1.01. What is the ratio of the Trade (in US$) in West Bank and Gaza in 1999 to that in 2000?
Ensure brevity in your answer.  1.16. What is the difference between the highest and the second highest Trade (in US$) of Russian Federation?
Give a very brief answer. 1.12e+1. What is the difference between the highest and the second highest Trade (in US$) in St. Lucia?
Keep it short and to the point. 7.96e+05. What is the difference between the highest and the second highest Trade (in US$) of Suriname?
Keep it short and to the point. 1.73e+08. What is the difference between the highest and the second highest Trade (in US$) of West Bank and Gaza?
Make the answer very short. 4.66e+08. What is the difference between the highest and the lowest Trade (in US$) of Russian Federation?
Your answer should be compact. 5.11e+1. What is the difference between the highest and the lowest Trade (in US$) in St. Lucia?
Your answer should be compact. 5.79e+07. What is the difference between the highest and the lowest Trade (in US$) of Suriname?
Make the answer very short. 3.07e+08. What is the difference between the highest and the lowest Trade (in US$) of West Bank and Gaza?
Give a very brief answer. 9.24e+08. 